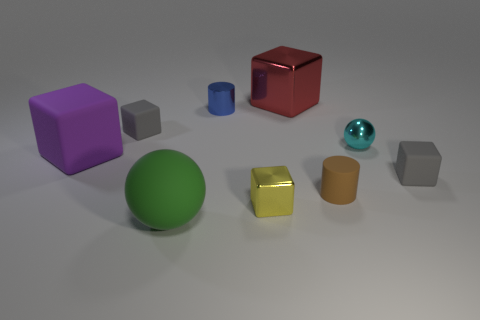Does the large green thing have the same shape as the gray object right of the small cyan thing? no 